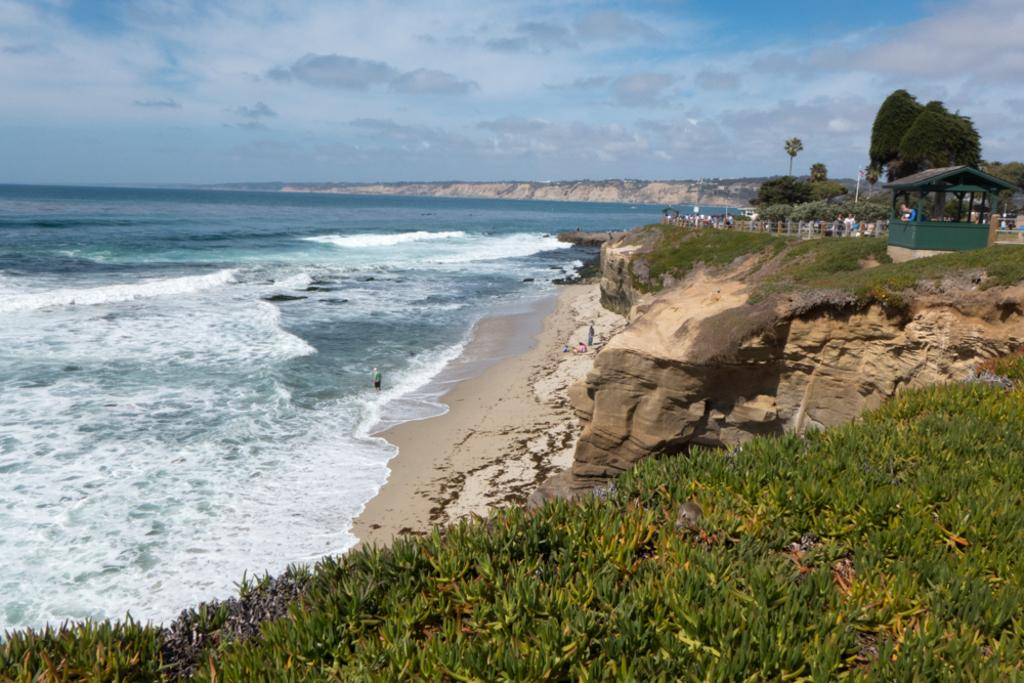What type of vegetation is present on the ground in the image? There is greenery on the ground in the image. Can you describe the people in the image? There are persons in the image. What other natural elements can be seen in the image? There are trees in the image. What objects are located in the right corner of the image? There are other objects in the right corner of the image. What is present in the left corner of the image? There is water in the left corner of the image. How would you describe the sky in the image? The sky is cloudy in the image. What type of net can be seen in the image? There is no net present in the image. What color is the bottle in the image? There is no bottle present in the image. 